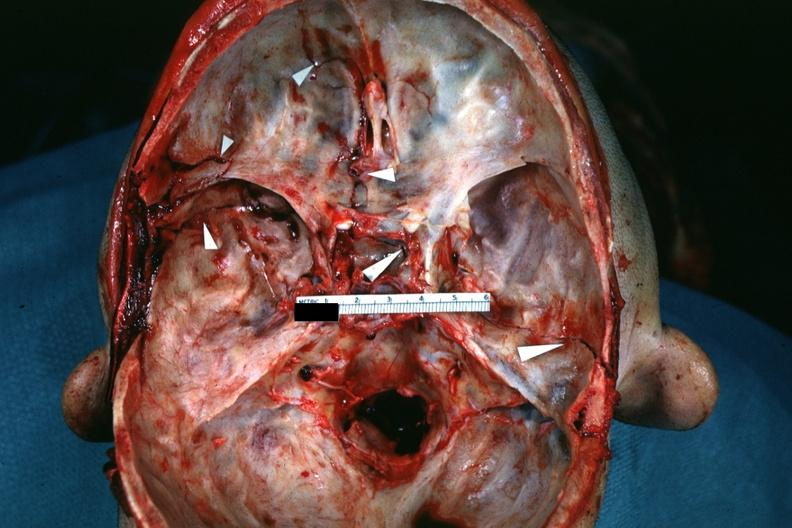s basilar skull fracture present?
Answer the question using a single word or phrase. Yes 